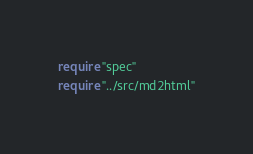Convert code to text. <code><loc_0><loc_0><loc_500><loc_500><_Crystal_>require "spec"
require "../src/md2html"
</code> 